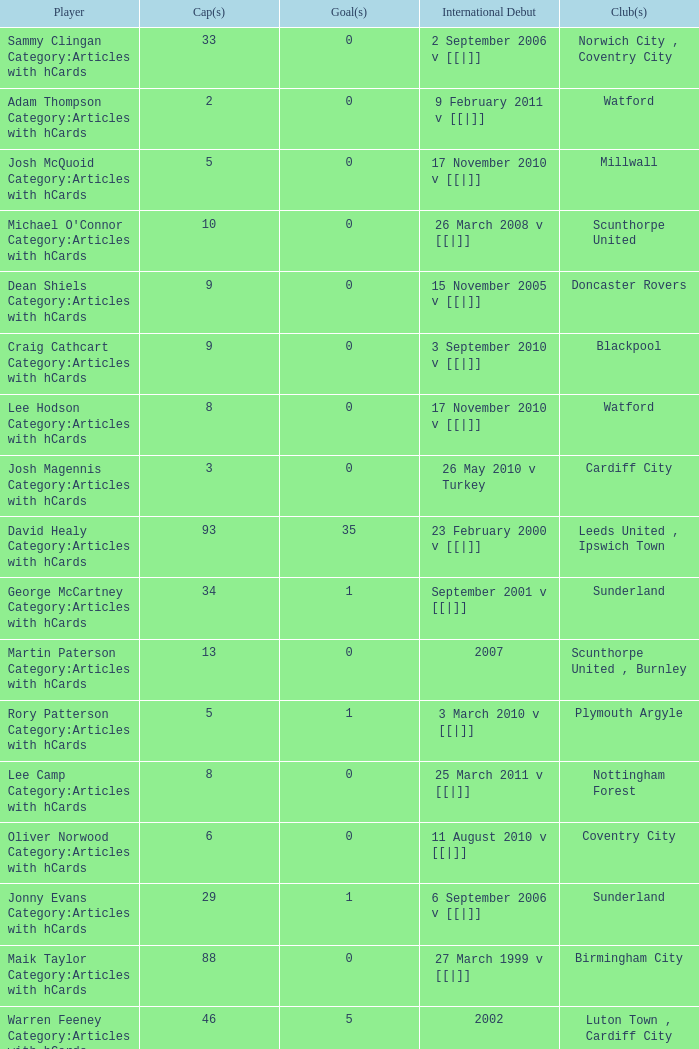How many players had 8 goals? 1.0. 